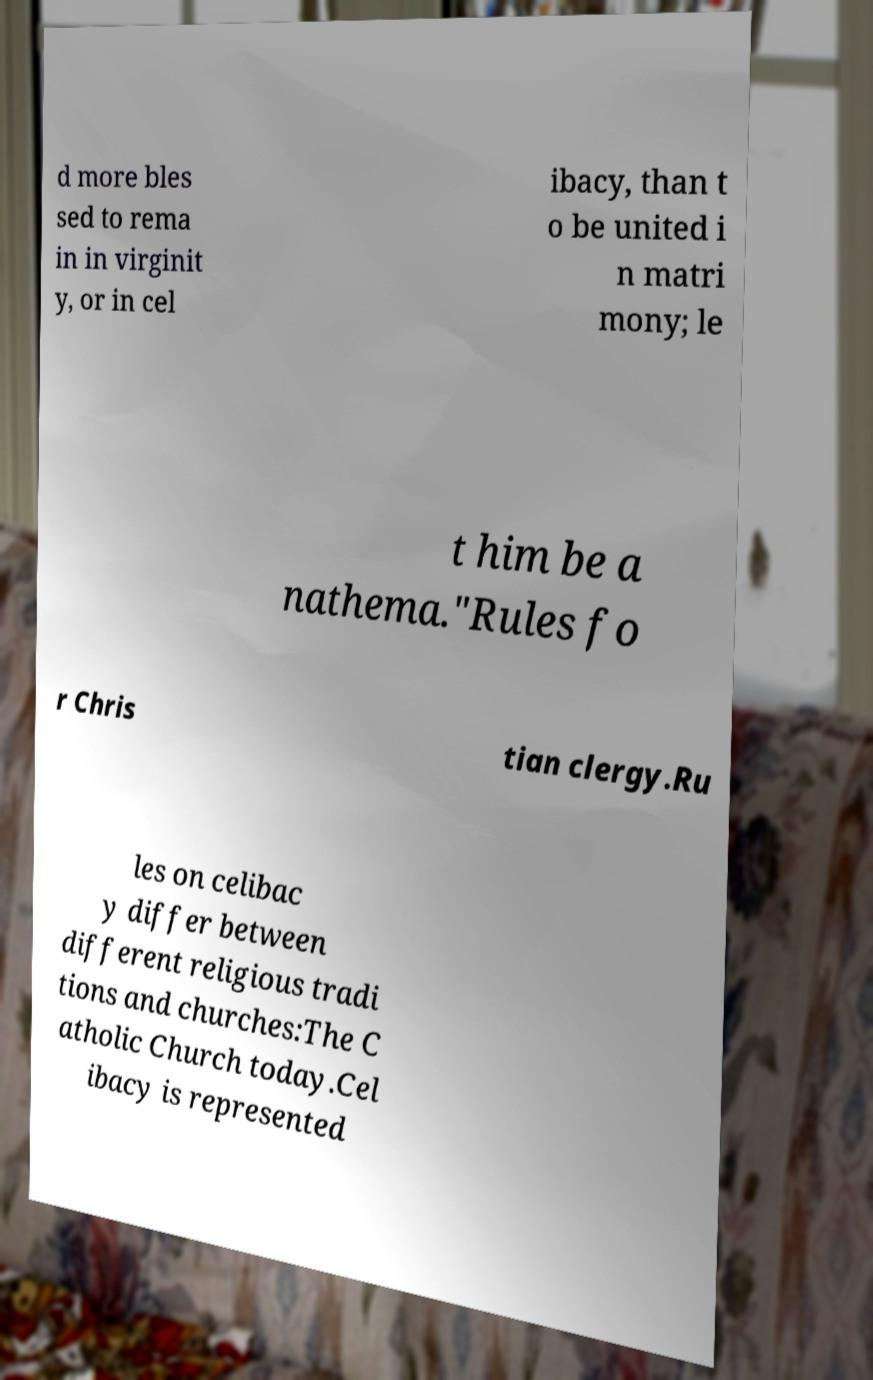There's text embedded in this image that I need extracted. Can you transcribe it verbatim? d more bles sed to rema in in virginit y, or in cel ibacy, than t o be united i n matri mony; le t him be a nathema."Rules fo r Chris tian clergy.Ru les on celibac y differ between different religious tradi tions and churches:The C atholic Church today.Cel ibacy is represented 